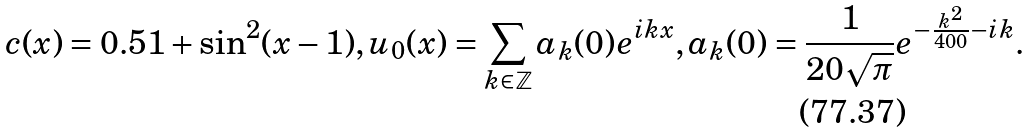Convert formula to latex. <formula><loc_0><loc_0><loc_500><loc_500>c ( x ) = 0 . 5 1 + \sin ^ { 2 } ( x - 1 ) , u _ { 0 } ( x ) = \sum _ { k \in \mathbb { Z } } a _ { k } ( 0 ) e ^ { i k x } , a _ { k } ( 0 ) = \frac { 1 } { 2 0 \sqrt { \pi } } e ^ { - \frac { k ^ { 2 } } { 4 0 0 } - i k } .</formula> 